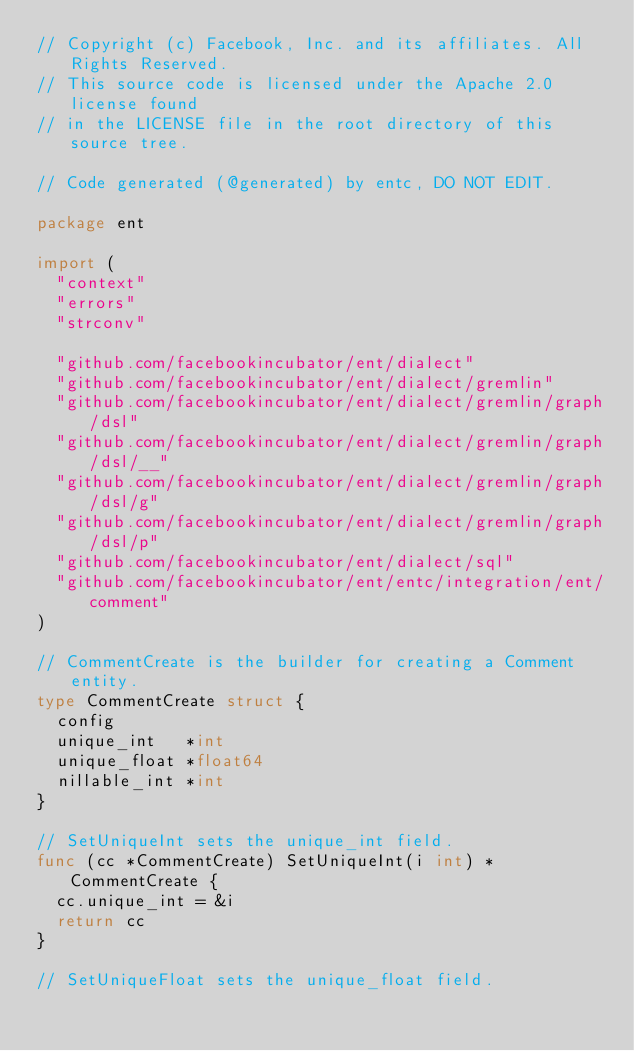Convert code to text. <code><loc_0><loc_0><loc_500><loc_500><_Go_>// Copyright (c) Facebook, Inc. and its affiliates. All Rights Reserved.
// This source code is licensed under the Apache 2.0 license found
// in the LICENSE file in the root directory of this source tree.

// Code generated (@generated) by entc, DO NOT EDIT.

package ent

import (
	"context"
	"errors"
	"strconv"

	"github.com/facebookincubator/ent/dialect"
	"github.com/facebookincubator/ent/dialect/gremlin"
	"github.com/facebookincubator/ent/dialect/gremlin/graph/dsl"
	"github.com/facebookincubator/ent/dialect/gremlin/graph/dsl/__"
	"github.com/facebookincubator/ent/dialect/gremlin/graph/dsl/g"
	"github.com/facebookincubator/ent/dialect/gremlin/graph/dsl/p"
	"github.com/facebookincubator/ent/dialect/sql"
	"github.com/facebookincubator/ent/entc/integration/ent/comment"
)

// CommentCreate is the builder for creating a Comment entity.
type CommentCreate struct {
	config
	unique_int   *int
	unique_float *float64
	nillable_int *int
}

// SetUniqueInt sets the unique_int field.
func (cc *CommentCreate) SetUniqueInt(i int) *CommentCreate {
	cc.unique_int = &i
	return cc
}

// SetUniqueFloat sets the unique_float field.</code> 